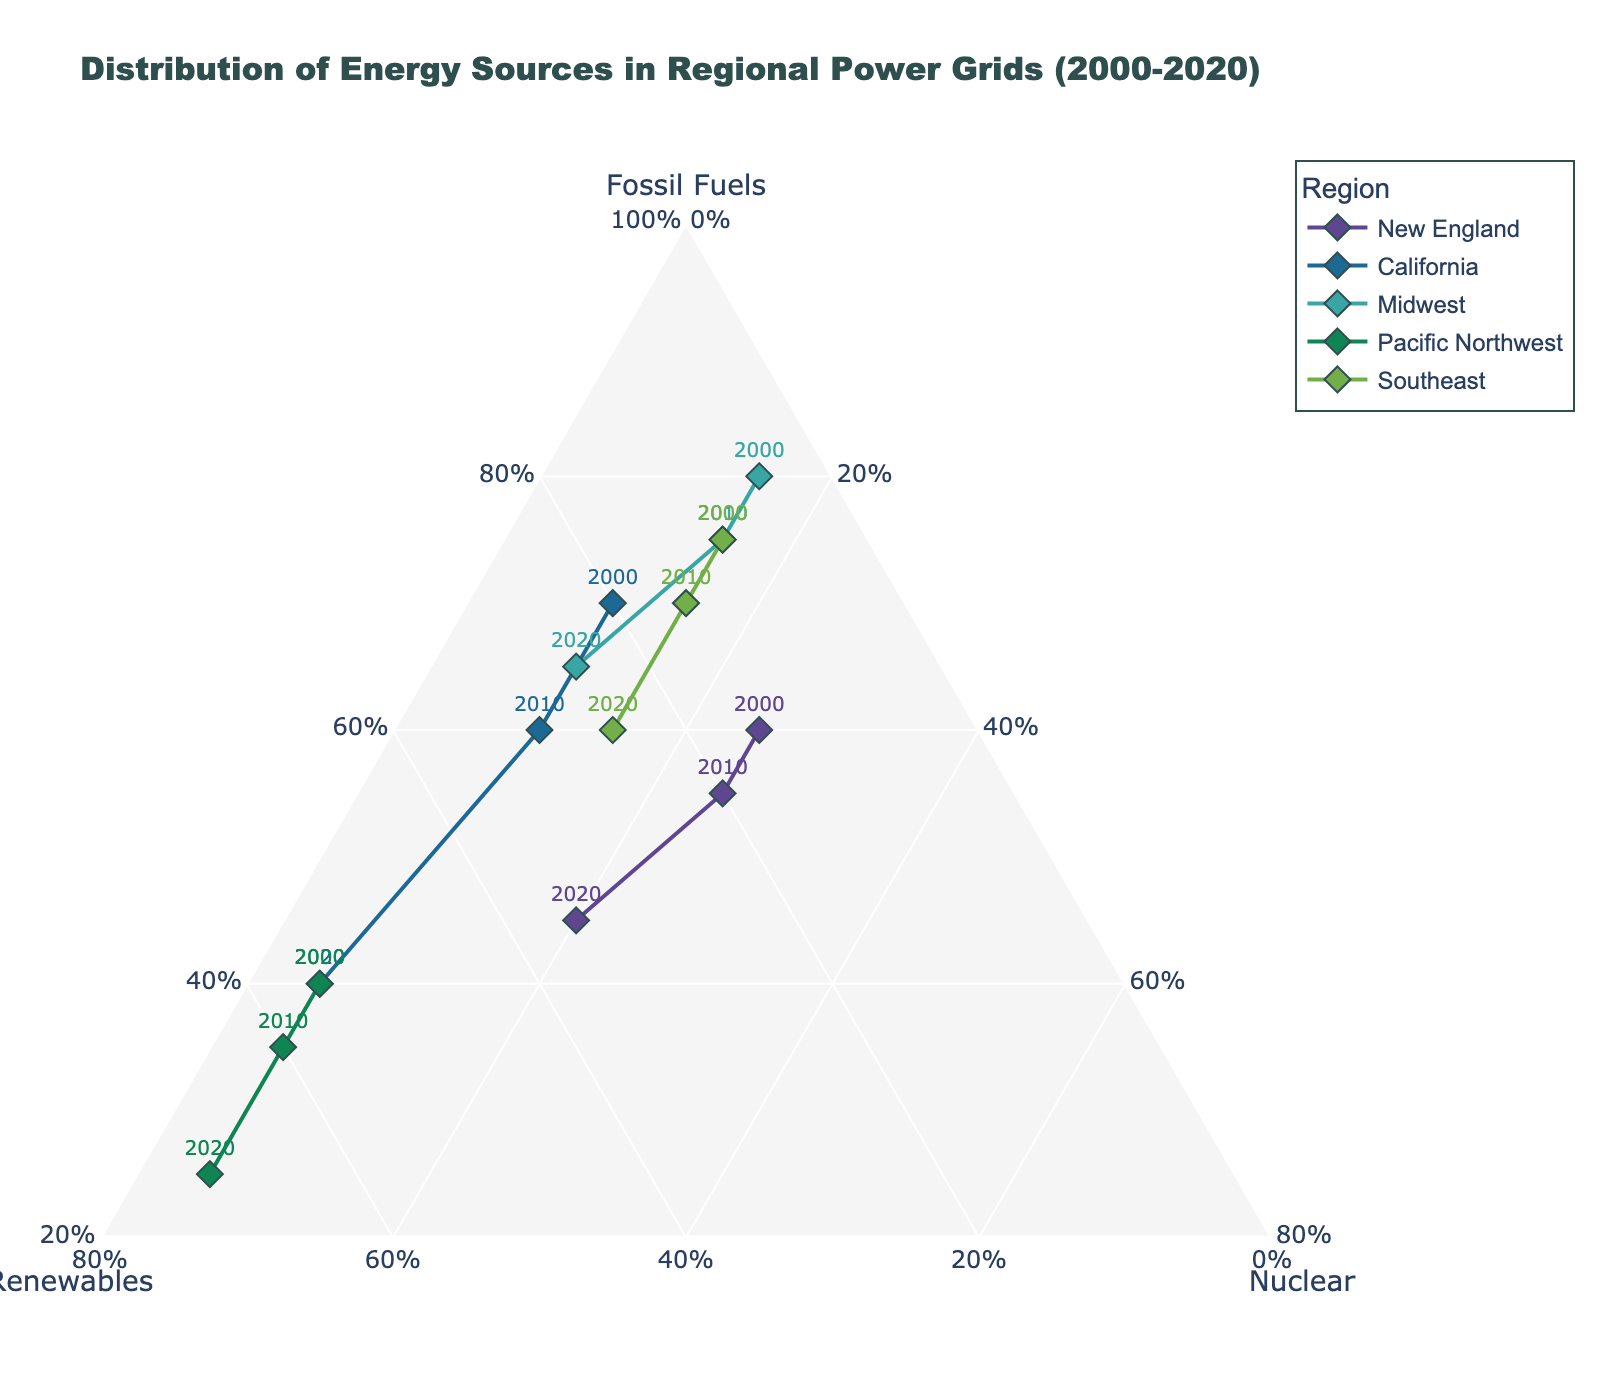What is the title of the figure? The title of the figure is usually at the top, centrally located. In this case, the title is "Distribution of Energy Sources in Regional Power Grids (2000-2020)."
Answer: Distribution of Energy Sources in Regional Power Grids (2000-2020) Which axis represents "Renewables"? In a ternary plot, each axis represents a different category. From the layout description, the b-axis represents "Renewables."
Answer: b-axis How many regions are shown in the figure? The number of regions can be identified by counting the unique legends or names listed in the legend section. There are five regions: New England, California, Midwest, Pacific Northwest, and Southeast.
Answer: 5 What was the highest percentage of renewables achieved by any region by 2020? To find this, look at the 2020 data points and observe the 'b' axis (renewables) percentages. The Pacific Northwest has the highest renewables percentage with 70% in 2020.
Answer: 70% Which region showed the largest decrease in fossil fuels from 2000 to 2020? Calculate the difference in fossil fuels for each region between 2000 and 2020. The difference for New England is 0.60 - 0.45 = 0.15, for California 0.70 - 0.40 = 0.30, for Midwest 0.80 - 0.65 = 0.15, for Pacific Northwest 0.40 - 0.25 = 0.15, and for Southeast 0.75 - 0.60 = 0.15. California had the largest decrease of 0.30.
Answer: California Which region had the most balanced energy sources in 2000? For balance, a region would have similar percentages for fossil fuels, renewables, and nuclear. Check the 2000 data points: California (0.70, 0.20, 0.10), Midwest (0.80, 0.05, 0.15), New England (0.60, 0.15, 0.25), Pacific Northwest (0.40, 0.55, 0.05), and Southeast (0.75, 0.10, 0.15). New England is the most balanced with percentages closer together.
Answer: New England In 2010, which region had the highest percentage of renewables? Compare the 2010 renewables percentages for all regions: New England 20%, California 30%, Midwest 10%, Pacific Northwest 60%, and Southeast 15%. The Pacific Northwest had the highest percentage at 60%.
Answer: Pacific Northwest How did the energy mix change for the Southeast region from 2000 to 2020? Examine the data points for Southeast in 2000 and 2020. In 2000: Fossil Fuels 75%, Renewables 10%, Nuclear 15%; in 2020: Fossil Fuels 60%, Renewables 25%, Nuclear 15%. The main changes are a decrease in fossil fuels (75% to 60%) and an increase in renewables (10% to 25%), with nuclear remaining the same.
Answer: Fossil Fuels decreased, Renewables increased, Nuclear stayed the same Which region showed the smallest change in nuclear energy contribution from 2000 to 2020? Look at the nuclear energy data for 2000 and 2020 for all regions. New England: 25% to 20% (5% change), California: 10% to 5% (5% change), Midwest: 15% to 10% (5% change), Pacific Northwest: constant at 5%, Southeast: constant at 15%. The Pacific Northwest and Southeast showed the smallest change, with no change.
Answer: Pacific Northwest and Southeast 